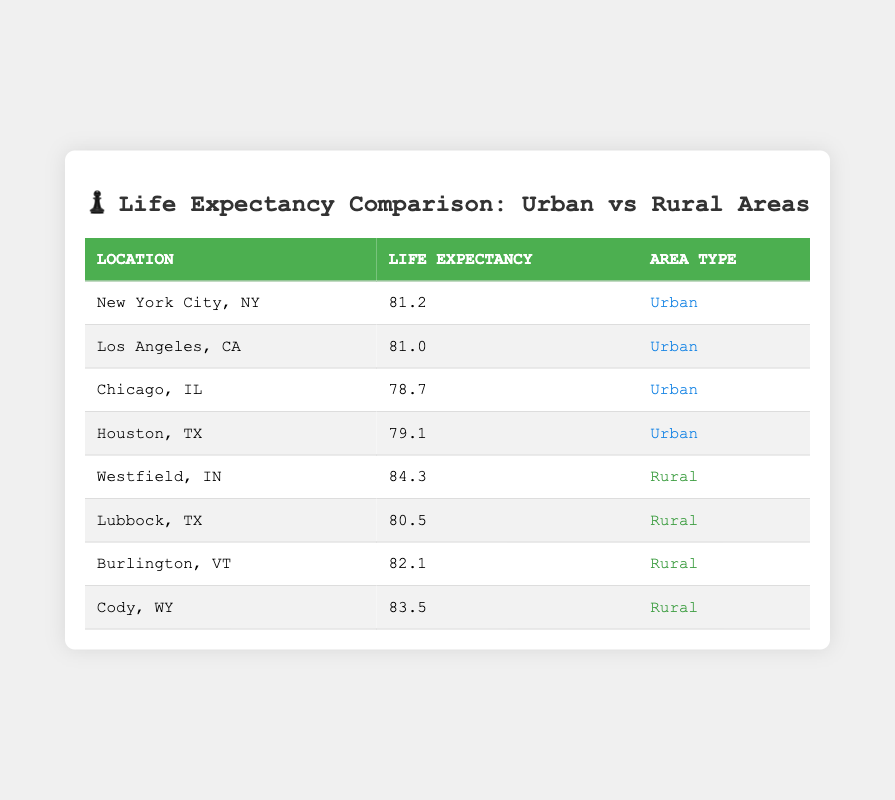What is the life expectancy in New York City? The table provides the life expectancy value for New York City, which is located under the "Life Expectancy" column. It shows that the value is 81.2.
Answer: 81.2 Which location has the highest life expectancy among rural areas? The rural areas listed are Westfield, IN (84.3), Lubbock, TX (80.5), Burlington, VT (82.1), and Cody, WY (83.5). Westfield, IN has the highest value at 84.3.
Answer: 84.3 Is the life expectancy in Chicago higher than in Houston? The life expectancy for Chicago is 78.7, while Houston's is 79.1. Since 78.7 is less than 79.1, the statement is false.
Answer: No What is the average life expectancy for urban areas listed? The urban life expectancy values are 81.2 (New York City), 81.0 (Los Angeles), 78.7 (Chicago), and 79.1 (Houston). Adding these values gives 320. The average is calculated by dividing by the number of urban locations: 320/4 = 80.0.
Answer: 80.0 Which rural area has the lowest life expectancy? From the rural area values: Westfield (84.3), Lubbock (80.5), Burlington (82.1), and Cody (83.5), the lowest value is Lubbock at 80.5.
Answer: 80.5 What is the difference in life expectancy between the highest urban area and the highest rural area? The highest urban life expectancy is from New York City at 81.2, and the highest rural area is Westfield at 84.3. The difference is calculated as 84.3 - 81.2 = 3.1.
Answer: 3.1 Is it true that the average life expectancy for rural areas is higher than that for urban areas? The average life expectancy for rural areas is (84.3 + 80.5 + 82.1 + 83.5) = 330. Dividing by 4 gives 82.5. The average for urban areas is previously calculated at 80. Therefore, 82.5 is greater than 80, making this statement true.
Answer: Yes Which city has a life expectancy closest to the overall average of the listed values? To find the overall average, add all life expectancy values (81.2 + 81.0 + 78.7 + 79.1 + 84.3 + 80.5 + 82.1 + 83.5) = 470.9, then divide by 8 for 58.86 (approx 81.4). The closest listed is New York City at 81.2.
Answer: 81.2 How many urban locations have a life expectancy above 80? The urban locations are New York City (81.2), Los Angeles (81.0), Chicago (78.7), and Houston (79.1). The first two are above 80, so there are 2 urban locations.
Answer: 2 